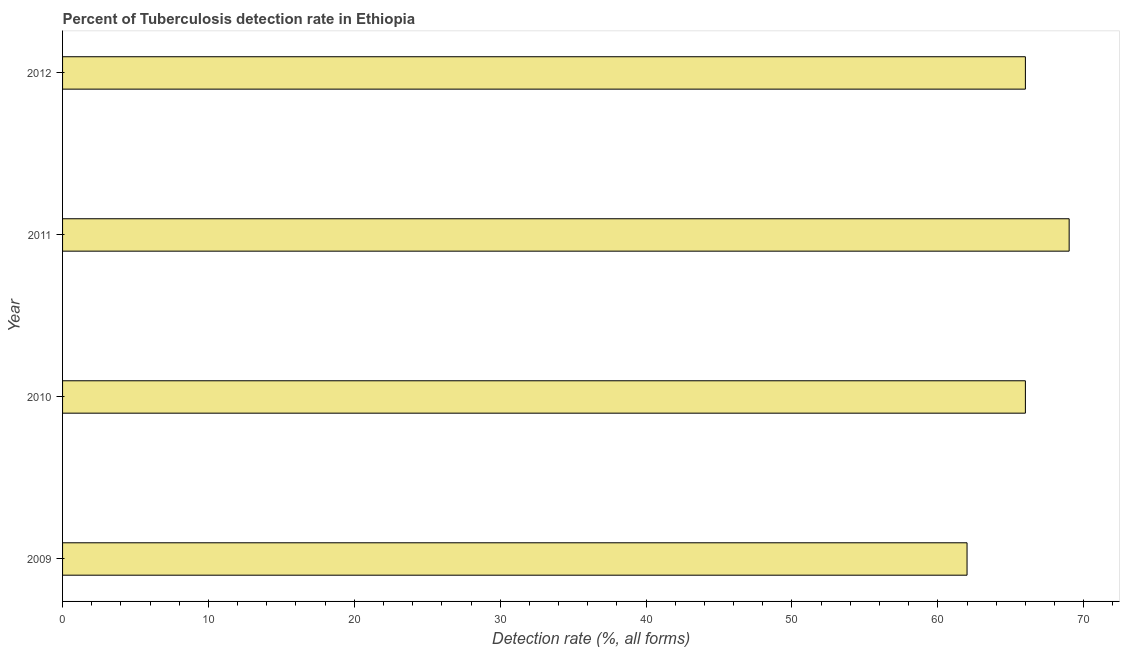Does the graph contain any zero values?
Make the answer very short. No. What is the title of the graph?
Make the answer very short. Percent of Tuberculosis detection rate in Ethiopia. What is the label or title of the X-axis?
Offer a terse response. Detection rate (%, all forms). What is the detection rate of tuberculosis in 2010?
Provide a short and direct response. 66. In which year was the detection rate of tuberculosis maximum?
Provide a succinct answer. 2011. In which year was the detection rate of tuberculosis minimum?
Your answer should be compact. 2009. What is the sum of the detection rate of tuberculosis?
Provide a succinct answer. 263. What is the difference between the detection rate of tuberculosis in 2009 and 2010?
Give a very brief answer. -4. What is the ratio of the detection rate of tuberculosis in 2009 to that in 2010?
Your answer should be compact. 0.94. Is the detection rate of tuberculosis in 2010 less than that in 2012?
Make the answer very short. No. Is the difference between the detection rate of tuberculosis in 2009 and 2011 greater than the difference between any two years?
Your response must be concise. Yes. In how many years, is the detection rate of tuberculosis greater than the average detection rate of tuberculosis taken over all years?
Your response must be concise. 3. How many bars are there?
Your answer should be very brief. 4. How many years are there in the graph?
Provide a succinct answer. 4. What is the difference between two consecutive major ticks on the X-axis?
Provide a short and direct response. 10. Are the values on the major ticks of X-axis written in scientific E-notation?
Offer a very short reply. No. What is the Detection rate (%, all forms) of 2009?
Make the answer very short. 62. What is the Detection rate (%, all forms) in 2012?
Provide a short and direct response. 66. What is the difference between the Detection rate (%, all forms) in 2009 and 2011?
Offer a terse response. -7. What is the difference between the Detection rate (%, all forms) in 2009 and 2012?
Your answer should be very brief. -4. What is the difference between the Detection rate (%, all forms) in 2011 and 2012?
Offer a very short reply. 3. What is the ratio of the Detection rate (%, all forms) in 2009 to that in 2010?
Ensure brevity in your answer.  0.94. What is the ratio of the Detection rate (%, all forms) in 2009 to that in 2011?
Your response must be concise. 0.9. What is the ratio of the Detection rate (%, all forms) in 2009 to that in 2012?
Provide a succinct answer. 0.94. What is the ratio of the Detection rate (%, all forms) in 2010 to that in 2011?
Your answer should be compact. 0.96. What is the ratio of the Detection rate (%, all forms) in 2010 to that in 2012?
Give a very brief answer. 1. What is the ratio of the Detection rate (%, all forms) in 2011 to that in 2012?
Make the answer very short. 1.04. 